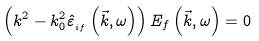<formula> <loc_0><loc_0><loc_500><loc_500>\left ( k ^ { 2 } - k _ { 0 } ^ { 2 } \hat { \varepsilon } _ { _ { i f } } \left ( \vec { k } , \omega \right ) \right ) E _ { f } \left ( \vec { k } , \omega \right ) = 0</formula> 